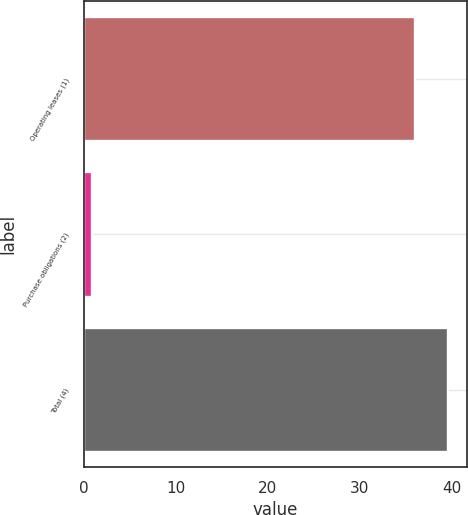<chart> <loc_0><loc_0><loc_500><loc_500><bar_chart><fcel>Operating leases (1)<fcel>Purchase obligations (2)<fcel>Total (4)<nl><fcel>36<fcel>0.9<fcel>39.62<nl></chart> 